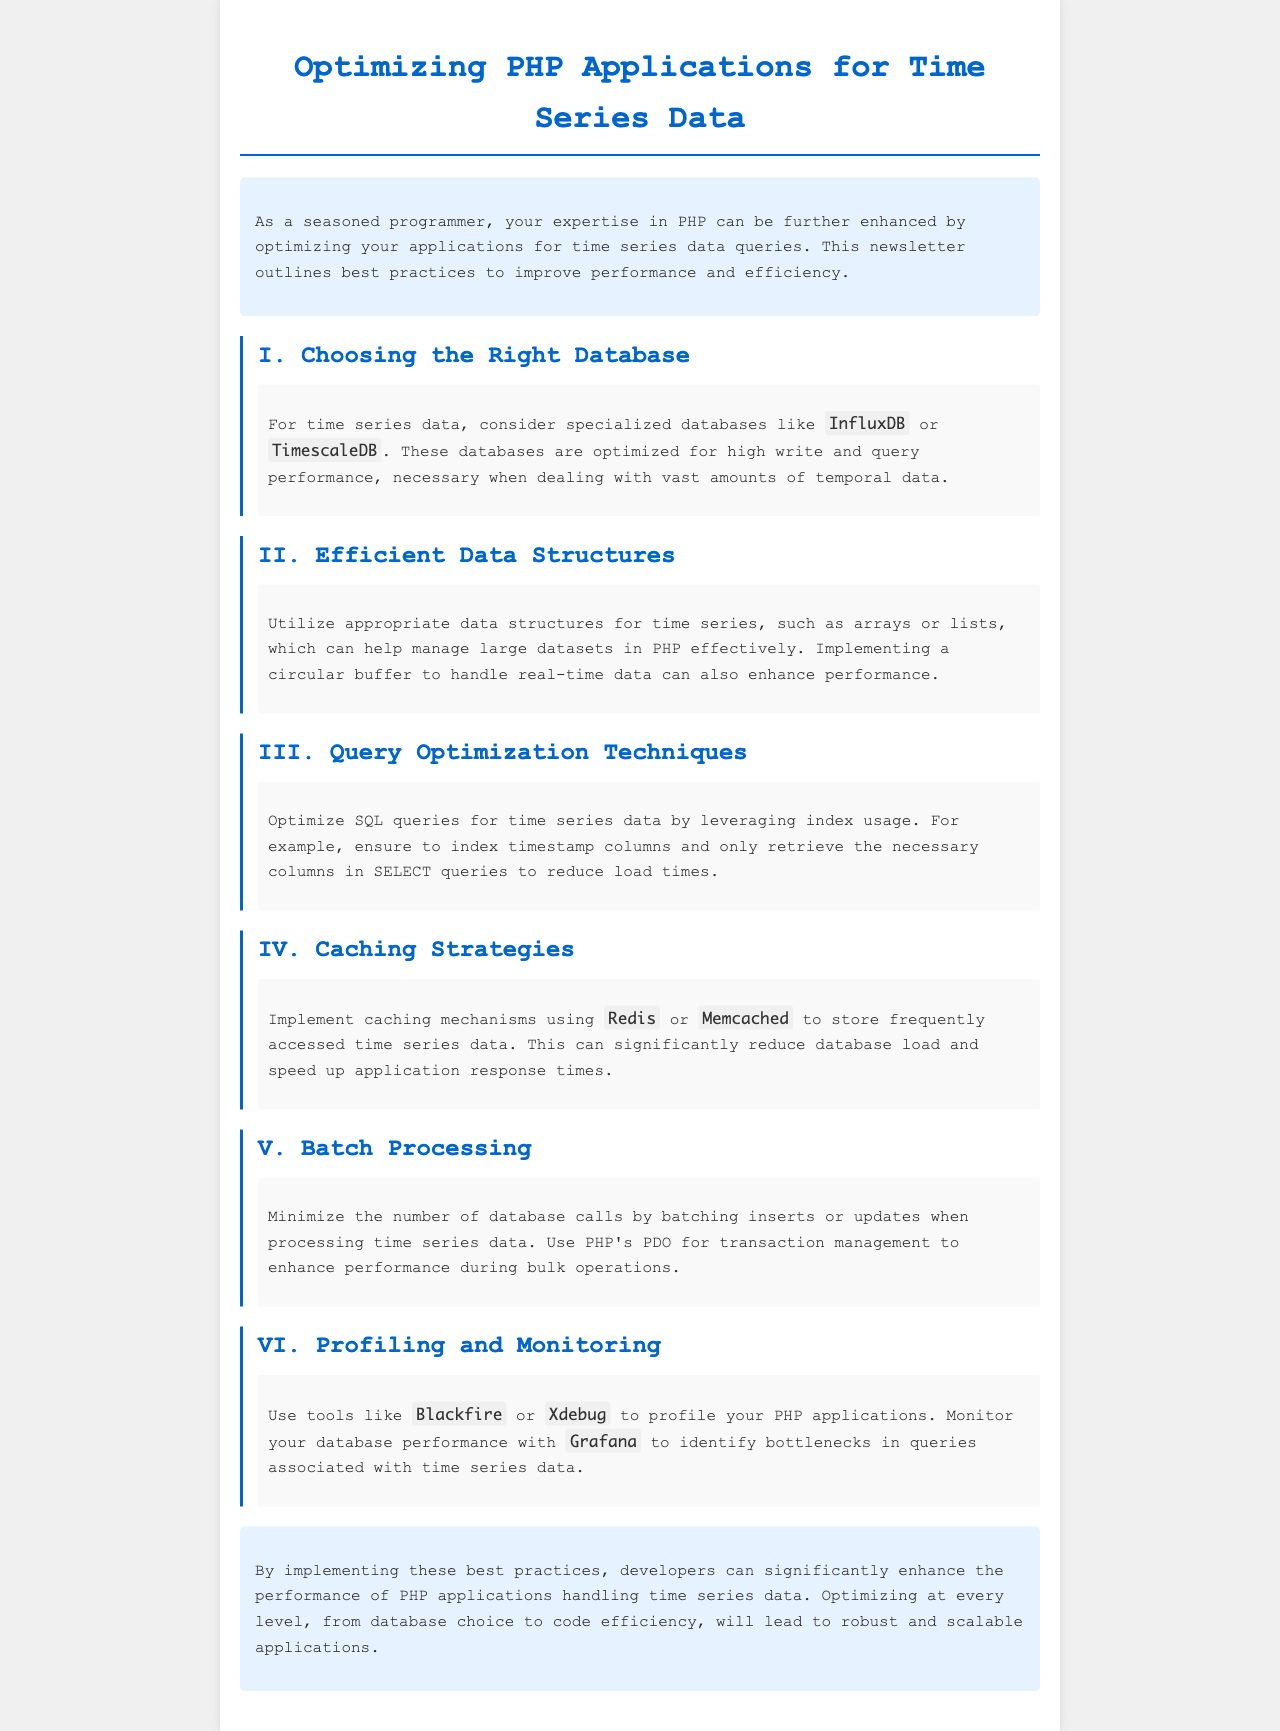What are specialized databases mentioned for time series data? The document suggests using specialized databases like InfluxDB or TimescaleDB for time series data.
Answer: InfluxDB, TimescaleDB What should be the structure used for handling real-time data? The document recommends implementing a circular buffer to manage real-time data effectively.
Answer: Circular buffer What caching mechanisms are suggested in the newsletter? The newsletter suggests using Redis or Memcached for caching frequently accessed time series data.
Answer: Redis, Memcached What tools can be used to profile PHP applications? The document mentions using Blackfire or Xdebug for profiling PHP applications.
Answer: Blackfire, Xdebug What is a recommended practice for processing time series data? The document recommends minimizing database calls by batching inserts or updates when processing time series data.
Answer: Batching inserts or updates What color is used for the section headings in the document? The document describes using a specific color for section headings that is #0066cc.
Answer: #0066cc Why is indexing timestamp columns important? Indexing timestamp columns is important as it optimizes SQL queries for time series data, reducing load times.
Answer: To reduce load times What does the conclusion emphasize regarding optimization? The conclusion emphasizes optimizing at every level to enhance performance in PHP applications handling time series data.
Answer: Optimize at every level 